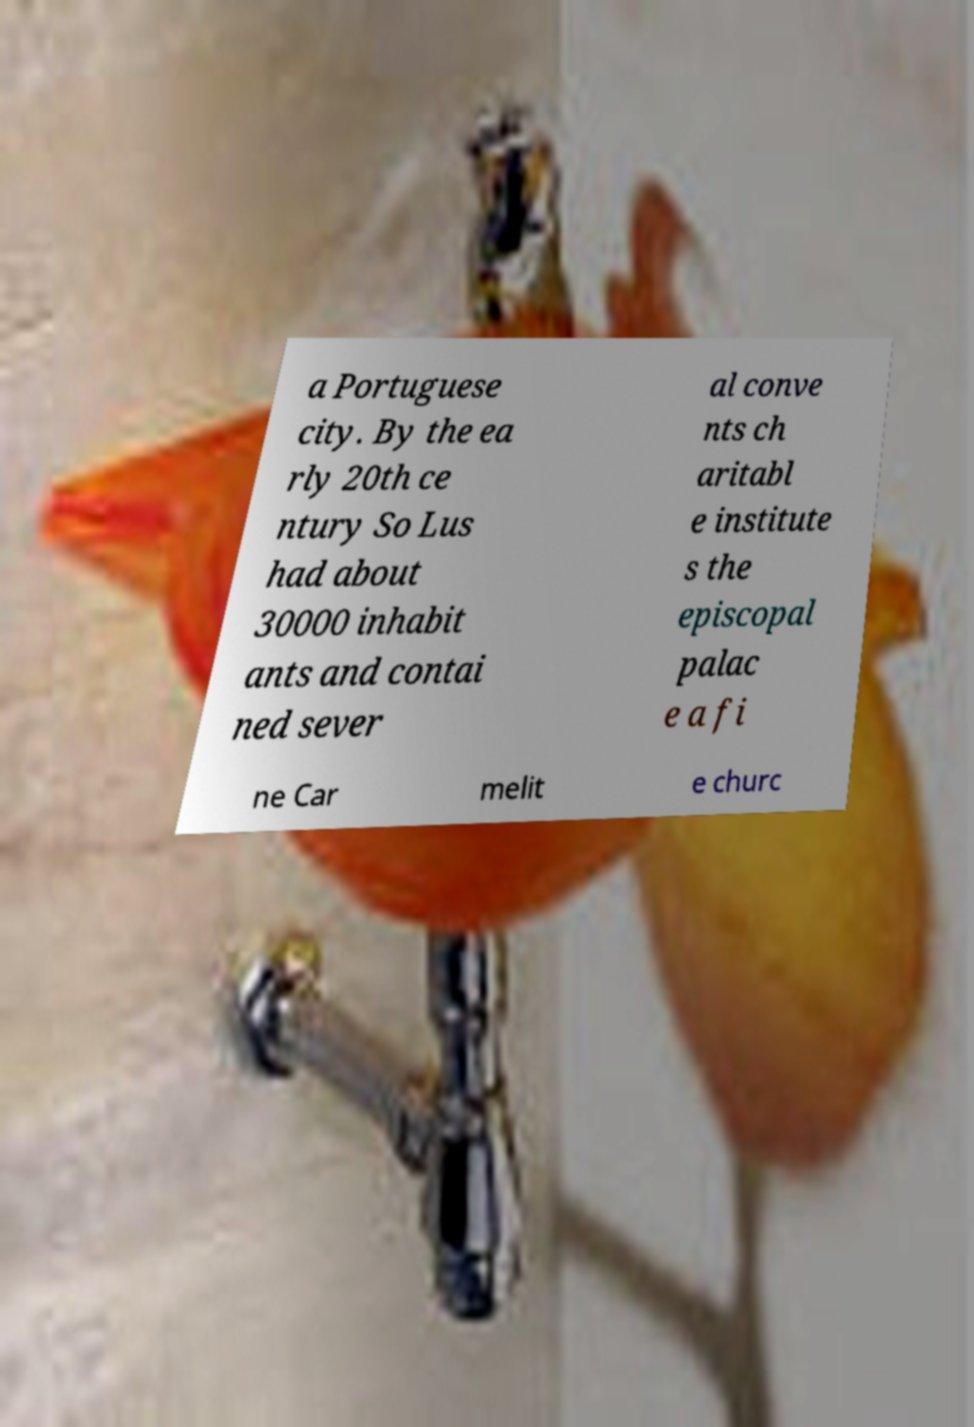Please read and relay the text visible in this image. What does it say? a Portuguese city. By the ea rly 20th ce ntury So Lus had about 30000 inhabit ants and contai ned sever al conve nts ch aritabl e institute s the episcopal palac e a fi ne Car melit e churc 